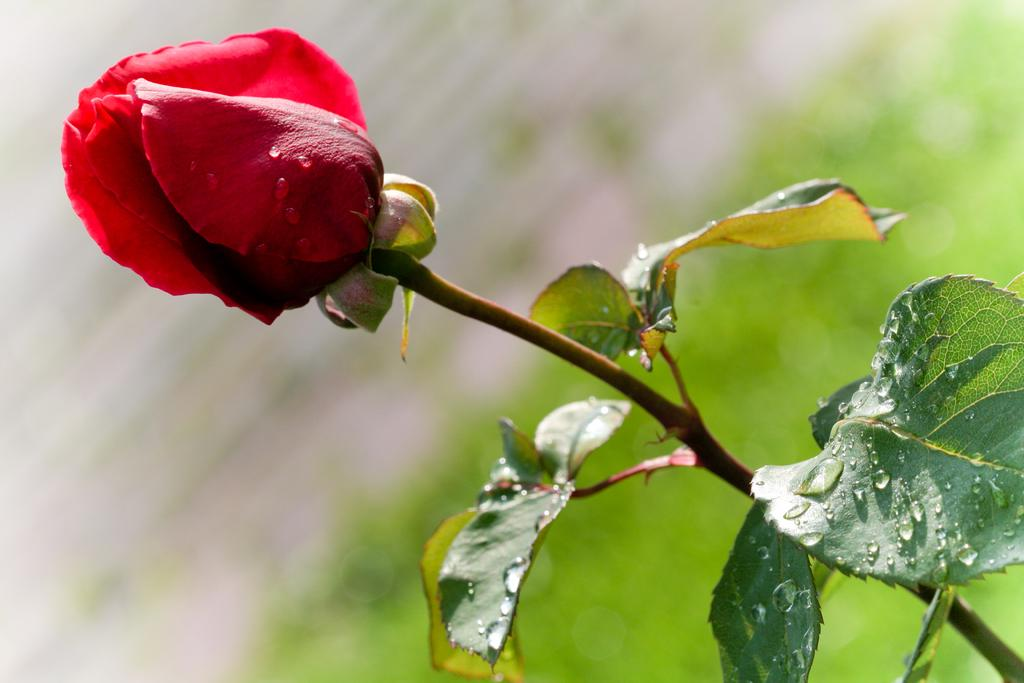What type of flower is in the image? There is a rose flower in the image. What part of the flower connects it to the stem? The rose flower has a stem. What colors can be seen in the background of the image? There is green and white color in the background of the image. What type of polish is applied to the clam in the image? There is no clam or polish present in the image; it features a rose flower with a stem and a green and white background. 